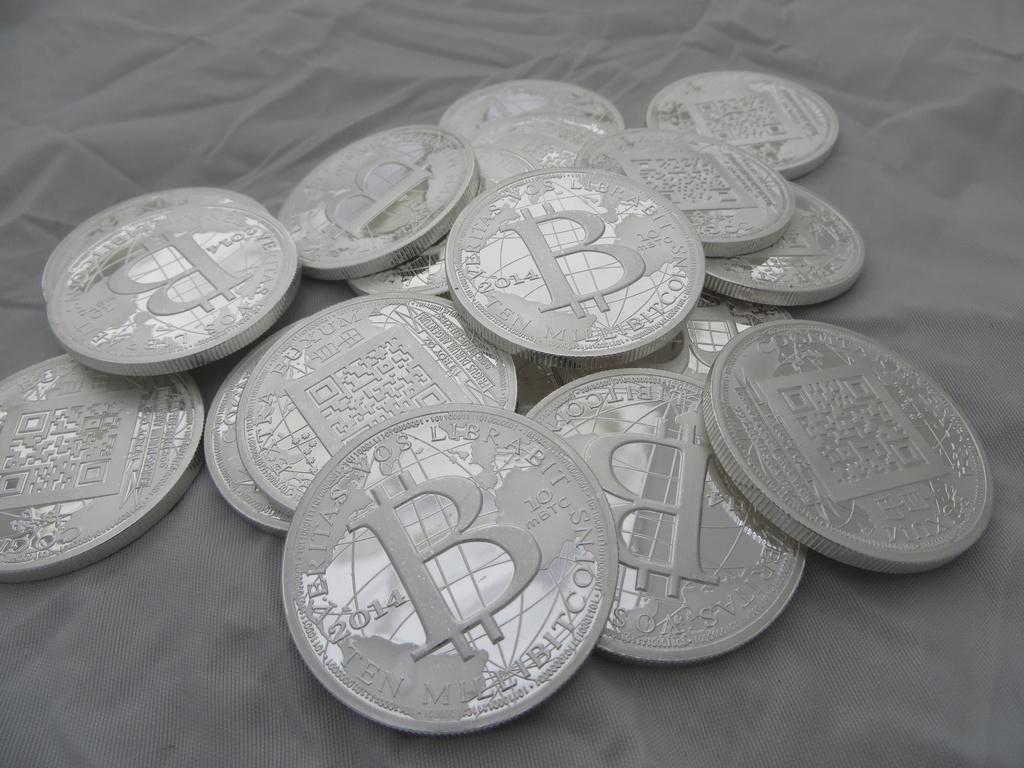What kind of currency is shown?
Keep it short and to the point. Bitcoin. How much is each coin worth?
Provide a short and direct response. Ten millibitcoins. 